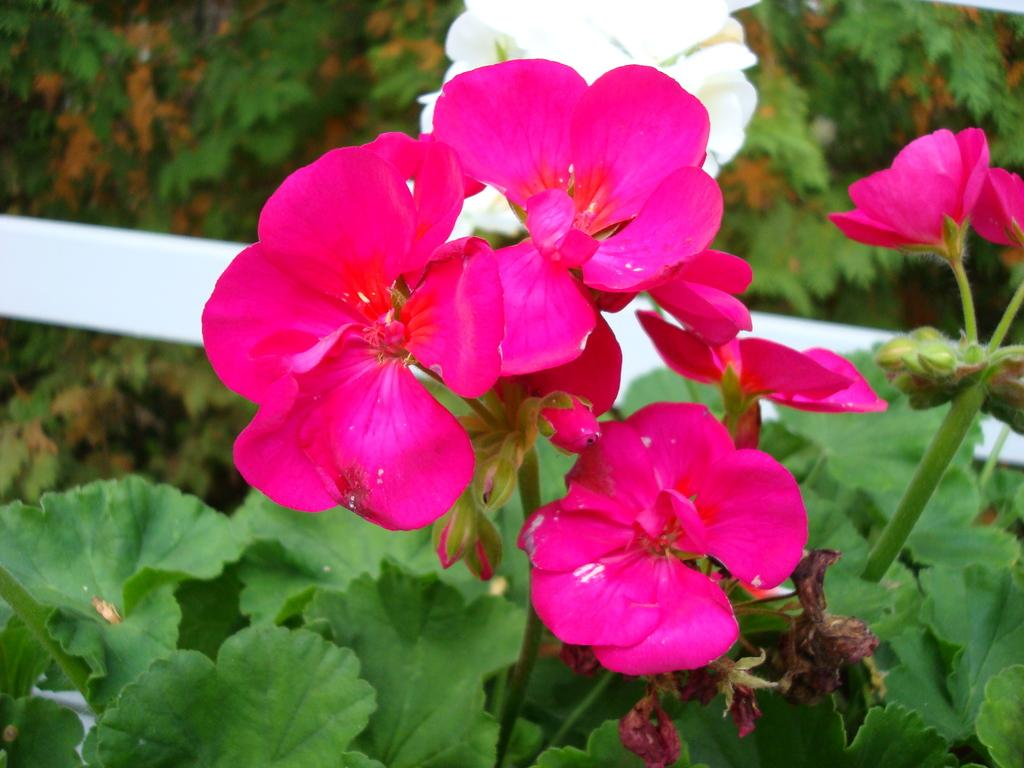What type of living organisms can be seen in the image? Plants can be seen in the image. What specific feature of the plants is visible? The plants have flowers. What colors are the flowers? The flowers are in pink and white colors. Is there any additional decoration or element in the image? Yes, there is a white color ribbon in the background of the image. How many pizzas are being burned in the image? There are no pizzas present in the image, and therefore no burning can be observed. 